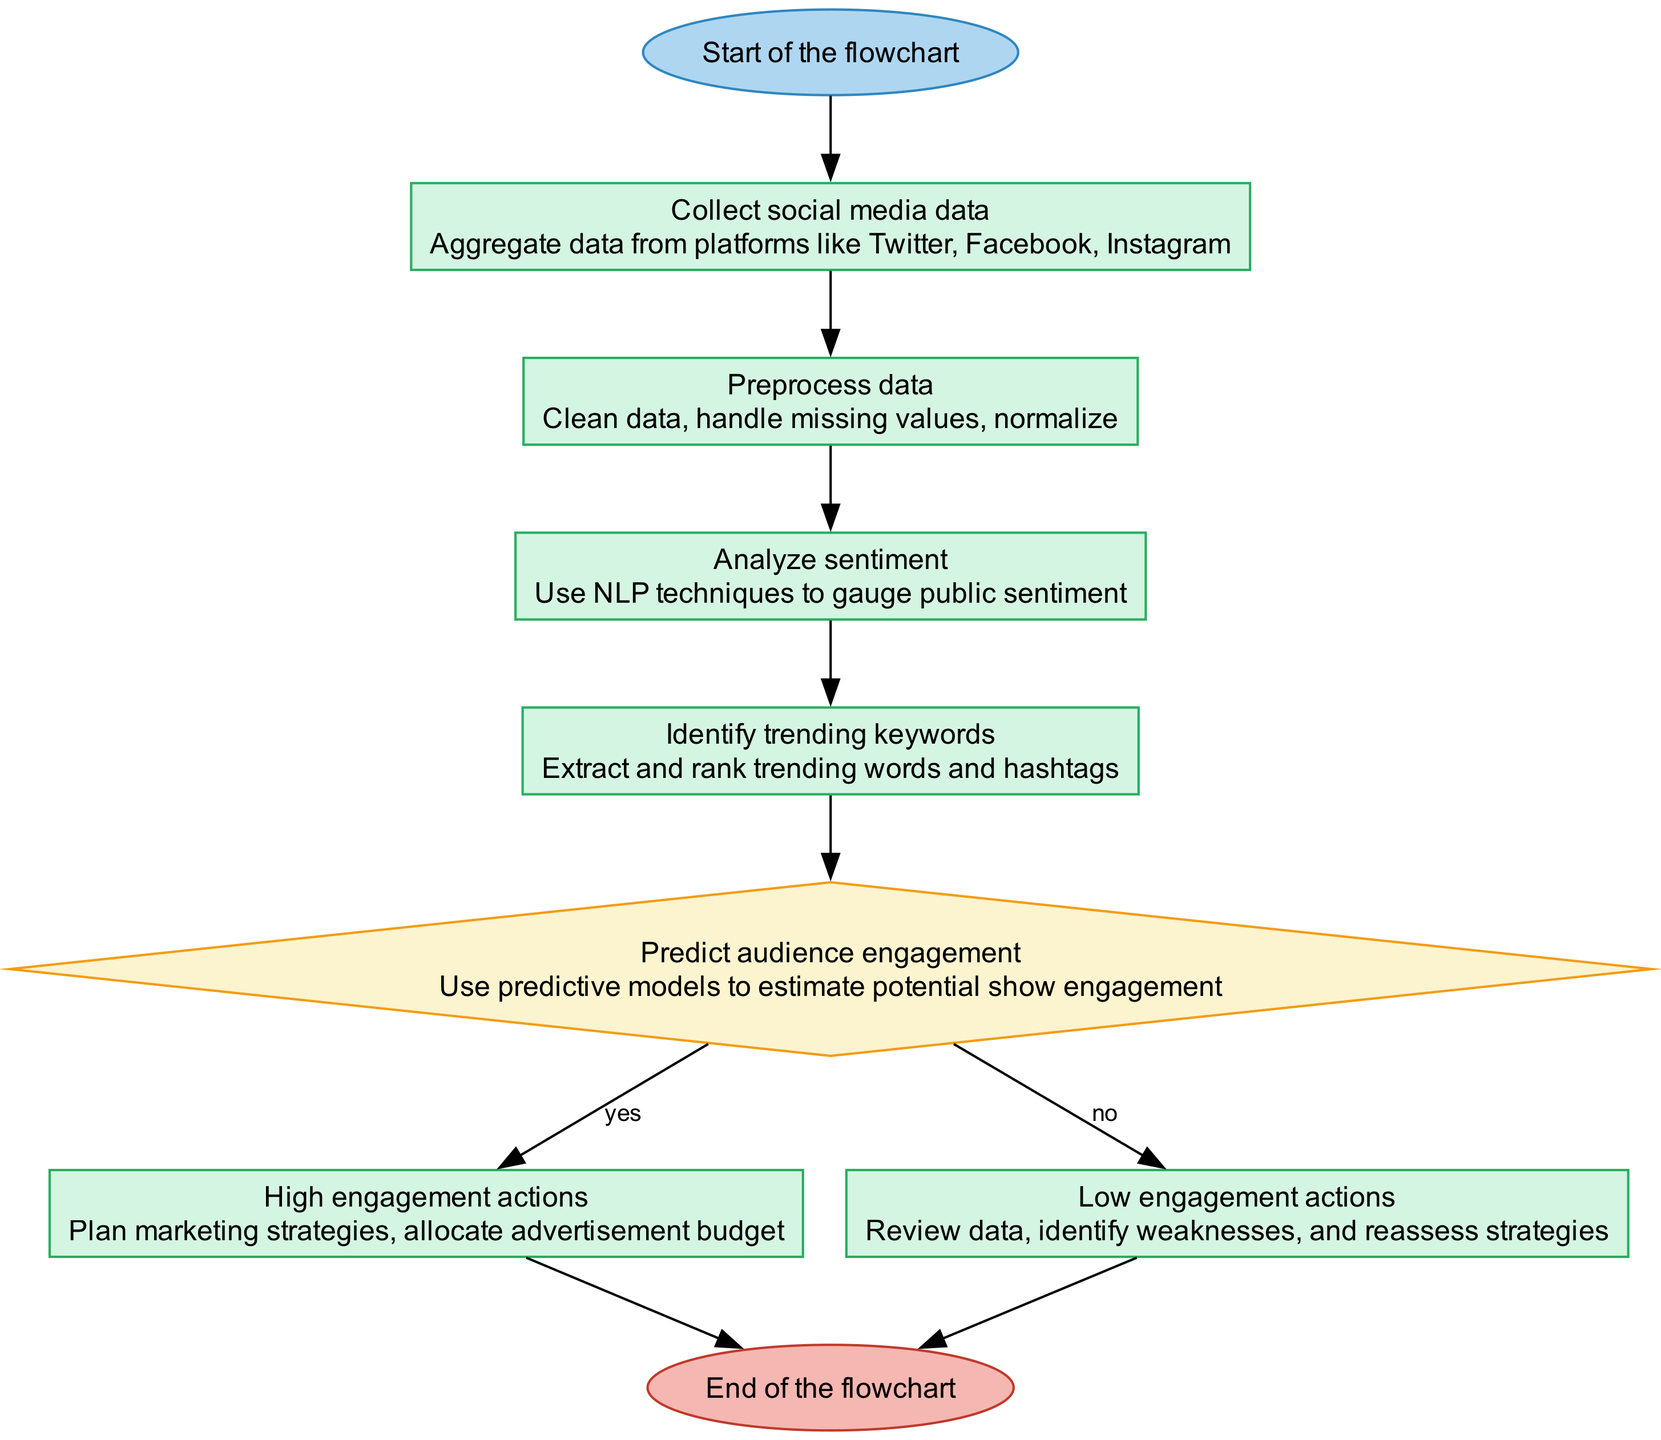What is the first step in the flowchart? The first step in the flowchart is indicated by the "start" node, which signifies the beginning of the process, leading to the next step of collecting social media data.
Answer: Collect social media data How many distinct processes are present in the flowchart? There are five distinct process nodes in the flowchart: collect social media data, preprocess data, analyze sentiment, identify trending keywords, and high engagement actions.
Answer: Five What action is taken if high engagement is predicted? If high engagement is predicted, the flow will proceed to the "high engagement" node, which details planning marketing strategies and allocating advertisement budget.
Answer: Plan marketing strategies Which node involves analyzing public sentiment? The node that involves analyzing public sentiment is "analyze sentiment," where NLP techniques are employed to gauge how the public feels about the new TV shows.
Answer: Analyze sentiment What happens after low engagement is predicted? After low engagement is predicted, the flow goes to the "low engagement actions" node, which involves reviewing data, identifying weaknesses, and reassessing strategies.
Answer: Review data How does the flowchart handle missing data? The flowchart handles missing data during the "preprocess data" step, where it specifies that the data needs to be cleaned, implying that handling missing values is part of this process.
Answer: Clean data What is the purpose of identifying trending keywords? Identifying trending keywords helps extract and rank popular words and hashtags, which offers insights into what is currently resonating with audiences on social media.
Answer: Extract and rank trending words If the prediction on audience engagement is uncertain, which decision is taken? The decision for uncertain predictions is not explicitly stated in the flowchart; however, if the prediction is “no,” the flow goes to “low engagement,” suggesting potential uncertainty leads to following that path.
Answer: Low engagement What type of diagram is this flowchart? This flowchart is a programming flowchart designed to illustrate a sequence of processes and decisions used for predicting audience engagement with new TV shows.
Answer: Programming flowchart 